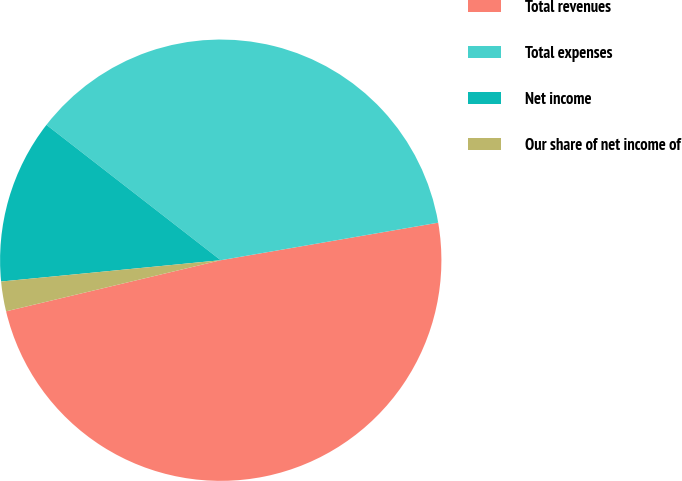Convert chart. <chart><loc_0><loc_0><loc_500><loc_500><pie_chart><fcel>Total revenues<fcel>Total expenses<fcel>Net income<fcel>Our share of net income of<nl><fcel>49.0%<fcel>36.77%<fcel>12.05%<fcel>2.18%<nl></chart> 